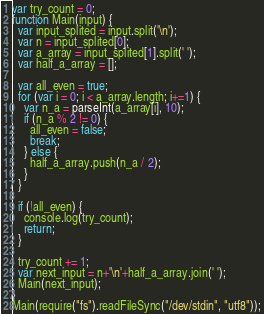<code> <loc_0><loc_0><loc_500><loc_500><_JavaScript_>var try_count = 0;
function Main(input) {
  var input_splited = input.split('\n');
  var n = input_splited[0];
  var a_array = input_splited[1].split(' ');
  var half_a_array = [];
  
  var all_even = true;
  for (var i = 0; i < a_array.length; i+=1) {
    var n_a = parseInt(a_array[i], 10);
    if (n_a % 2 != 0) {
      all_even = false;
      break;
    } else {
      half_a_array.push(n_a / 2);
    }
  }
 
  if (!all_even) {
    console.log(try_count);
    return;
  }

  try_count += 1;
  var next_input = n+'\n'+half_a_array.join(' ');
  Main(next_input);
}
Main(require("fs").readFileSync("/dev/stdin", "utf8"));</code> 